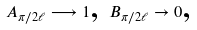<formula> <loc_0><loc_0><loc_500><loc_500>A _ { \pi / 2 \ell } \longrightarrow 1 \text {, } B _ { \pi / 2 \ell } \rightarrow 0 \text {,}</formula> 